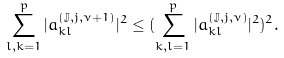<formula> <loc_0><loc_0><loc_500><loc_500>\sum _ { l , k = 1 } ^ { p } | a _ { k l } ^ { ( \mathbb { J } , j , \nu + 1 ) } | ^ { 2 } \leq ( \sum _ { k , l = 1 } ^ { p } | a _ { k l } ^ { ( \mathbb { J } , j , \nu ) } | ^ { 2 } ) ^ { 2 } .</formula> 